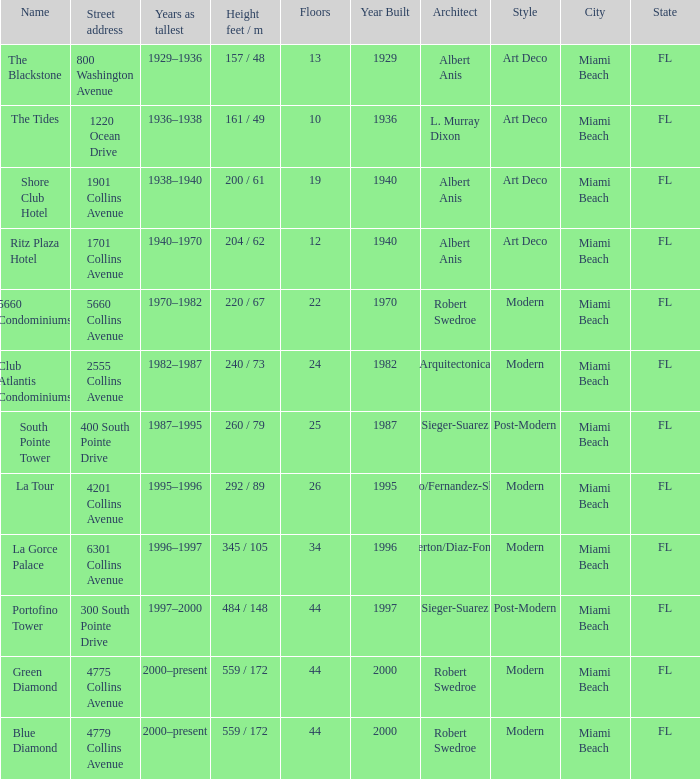How many years was the building with 24 floors the tallest? 1982–1987. 